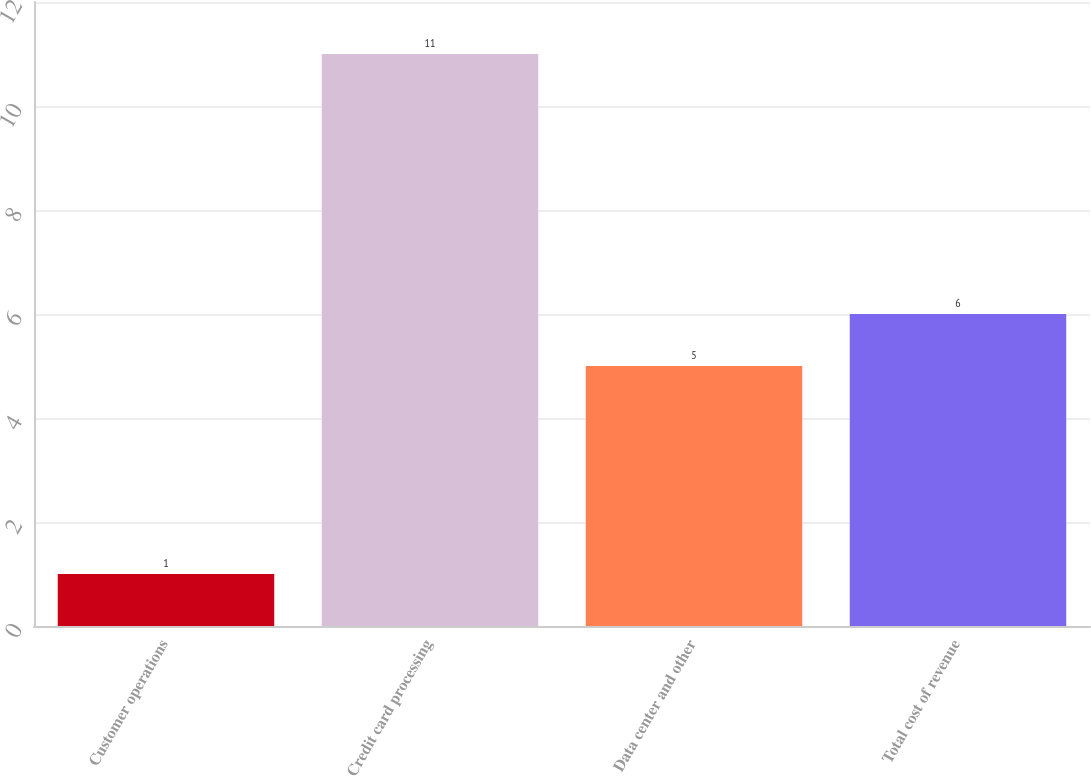Convert chart to OTSL. <chart><loc_0><loc_0><loc_500><loc_500><bar_chart><fcel>Customer operations<fcel>Credit card processing<fcel>Data center and other<fcel>Total cost of revenue<nl><fcel>1<fcel>11<fcel>5<fcel>6<nl></chart> 